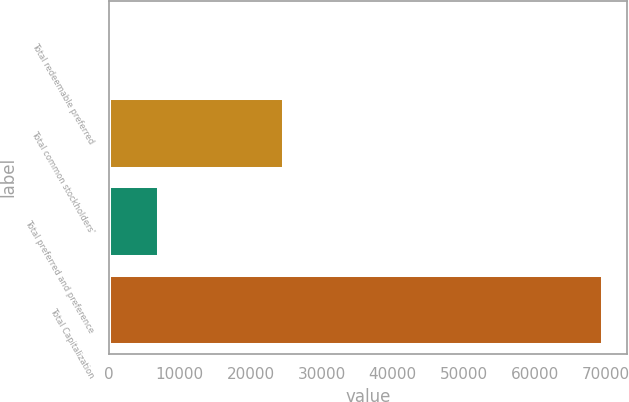Convert chart to OTSL. <chart><loc_0><loc_0><loc_500><loc_500><bar_chart><fcel>Total redeemable preferred<fcel>Total common stockholders'<fcel>Total preferred and preference<fcel>Total Capitalization<nl><fcel>118<fcel>24758<fcel>7058.5<fcel>69523<nl></chart> 